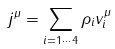<formula> <loc_0><loc_0><loc_500><loc_500>j ^ { \mu } = \sum _ { i = 1 \cdots 4 } \rho _ { i } v ^ { \mu } _ { i }</formula> 